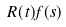<formula> <loc_0><loc_0><loc_500><loc_500>R ( t ) f ( s )</formula> 